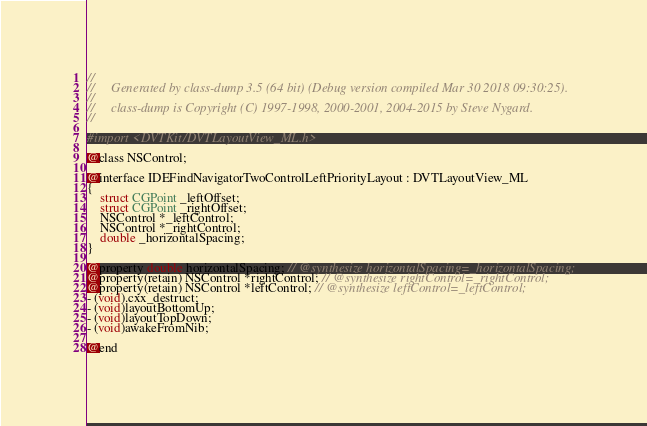<code> <loc_0><loc_0><loc_500><loc_500><_C_>//
//     Generated by class-dump 3.5 (64 bit) (Debug version compiled Mar 30 2018 09:30:25).
//
//     class-dump is Copyright (C) 1997-1998, 2000-2001, 2004-2015 by Steve Nygard.
//

#import <DVTKit/DVTLayoutView_ML.h>

@class NSControl;

@interface IDEFindNavigatorTwoControlLeftPriorityLayout : DVTLayoutView_ML
{
    struct CGPoint _leftOffset;
    struct CGPoint _rightOffset;
    NSControl *_leftControl;
    NSControl *_rightControl;
    double _horizontalSpacing;
}

@property double horizontalSpacing; // @synthesize horizontalSpacing=_horizontalSpacing;
@property(retain) NSControl *rightControl; // @synthesize rightControl=_rightControl;
@property(retain) NSControl *leftControl; // @synthesize leftControl=_leftControl;
- (void).cxx_destruct;
- (void)layoutBottomUp;
- (void)layoutTopDown;
- (void)awakeFromNib;

@end

</code> 